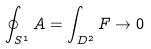<formula> <loc_0><loc_0><loc_500><loc_500>\oint _ { S ^ { 1 } } A = \int _ { D ^ { 2 } } F \to 0</formula> 